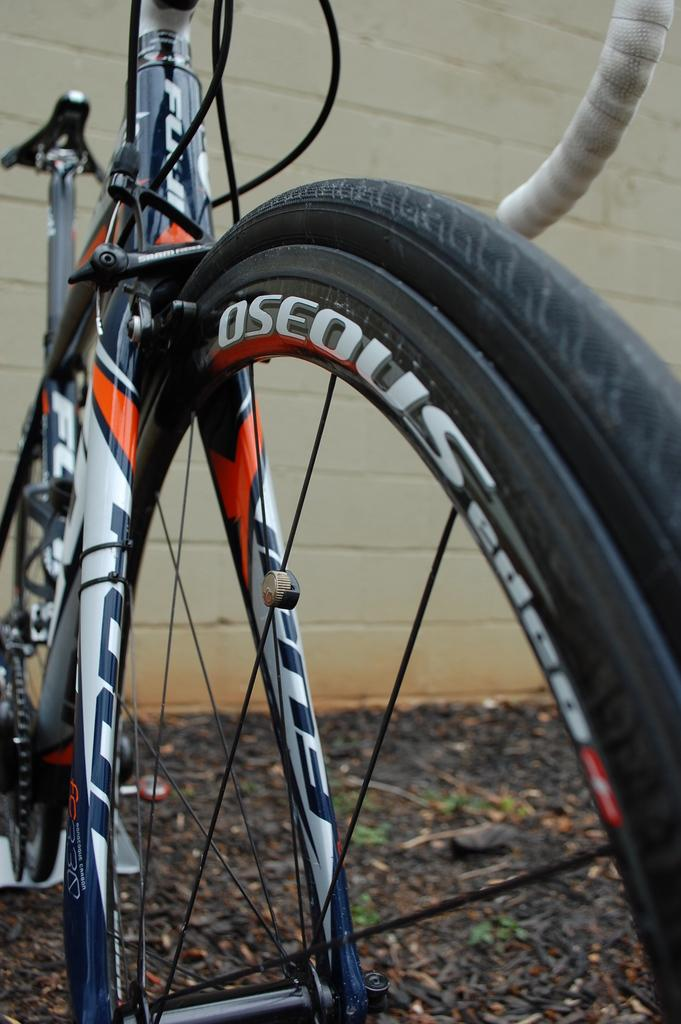What is the main subject of the image? The main subject of the image is a bicycle. Can you describe the bicycle in the image? The image is a zoomed in picture of a bicycle, so we can see details of the bicycle itself. What is visible in the background of the image? There is a wall in the background of the image. What title does the fireman hold in the image? There is no fireman or any indication of a title in the image; it is a picture of a bicycle with a wall in the background. 